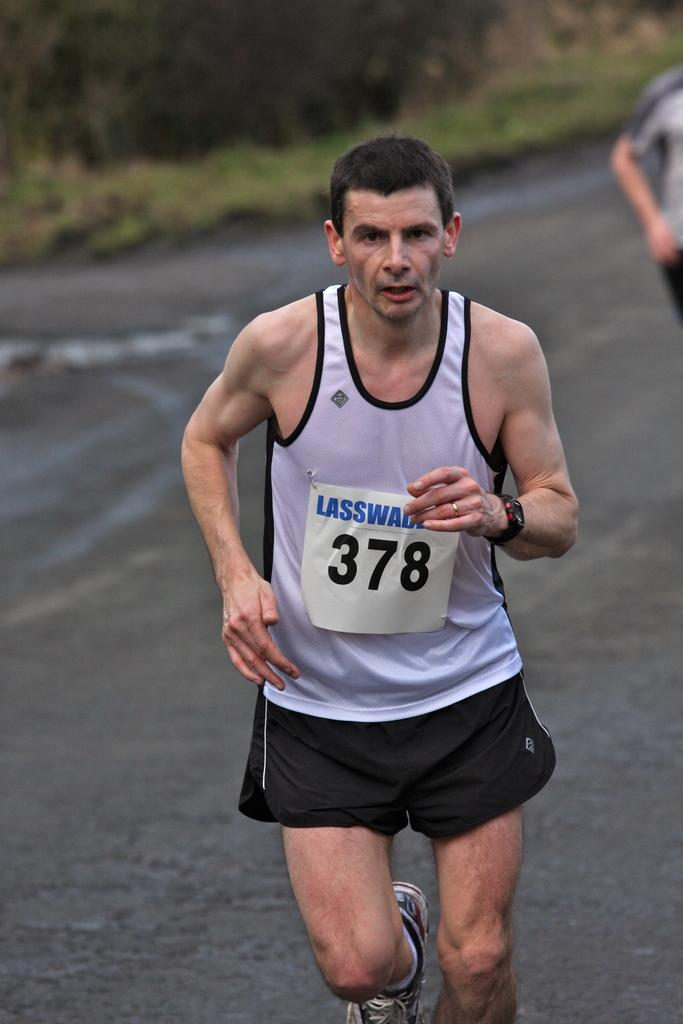<image>
Give a short and clear explanation of the subsequent image. A runner with the number 378 continues on in the race. 